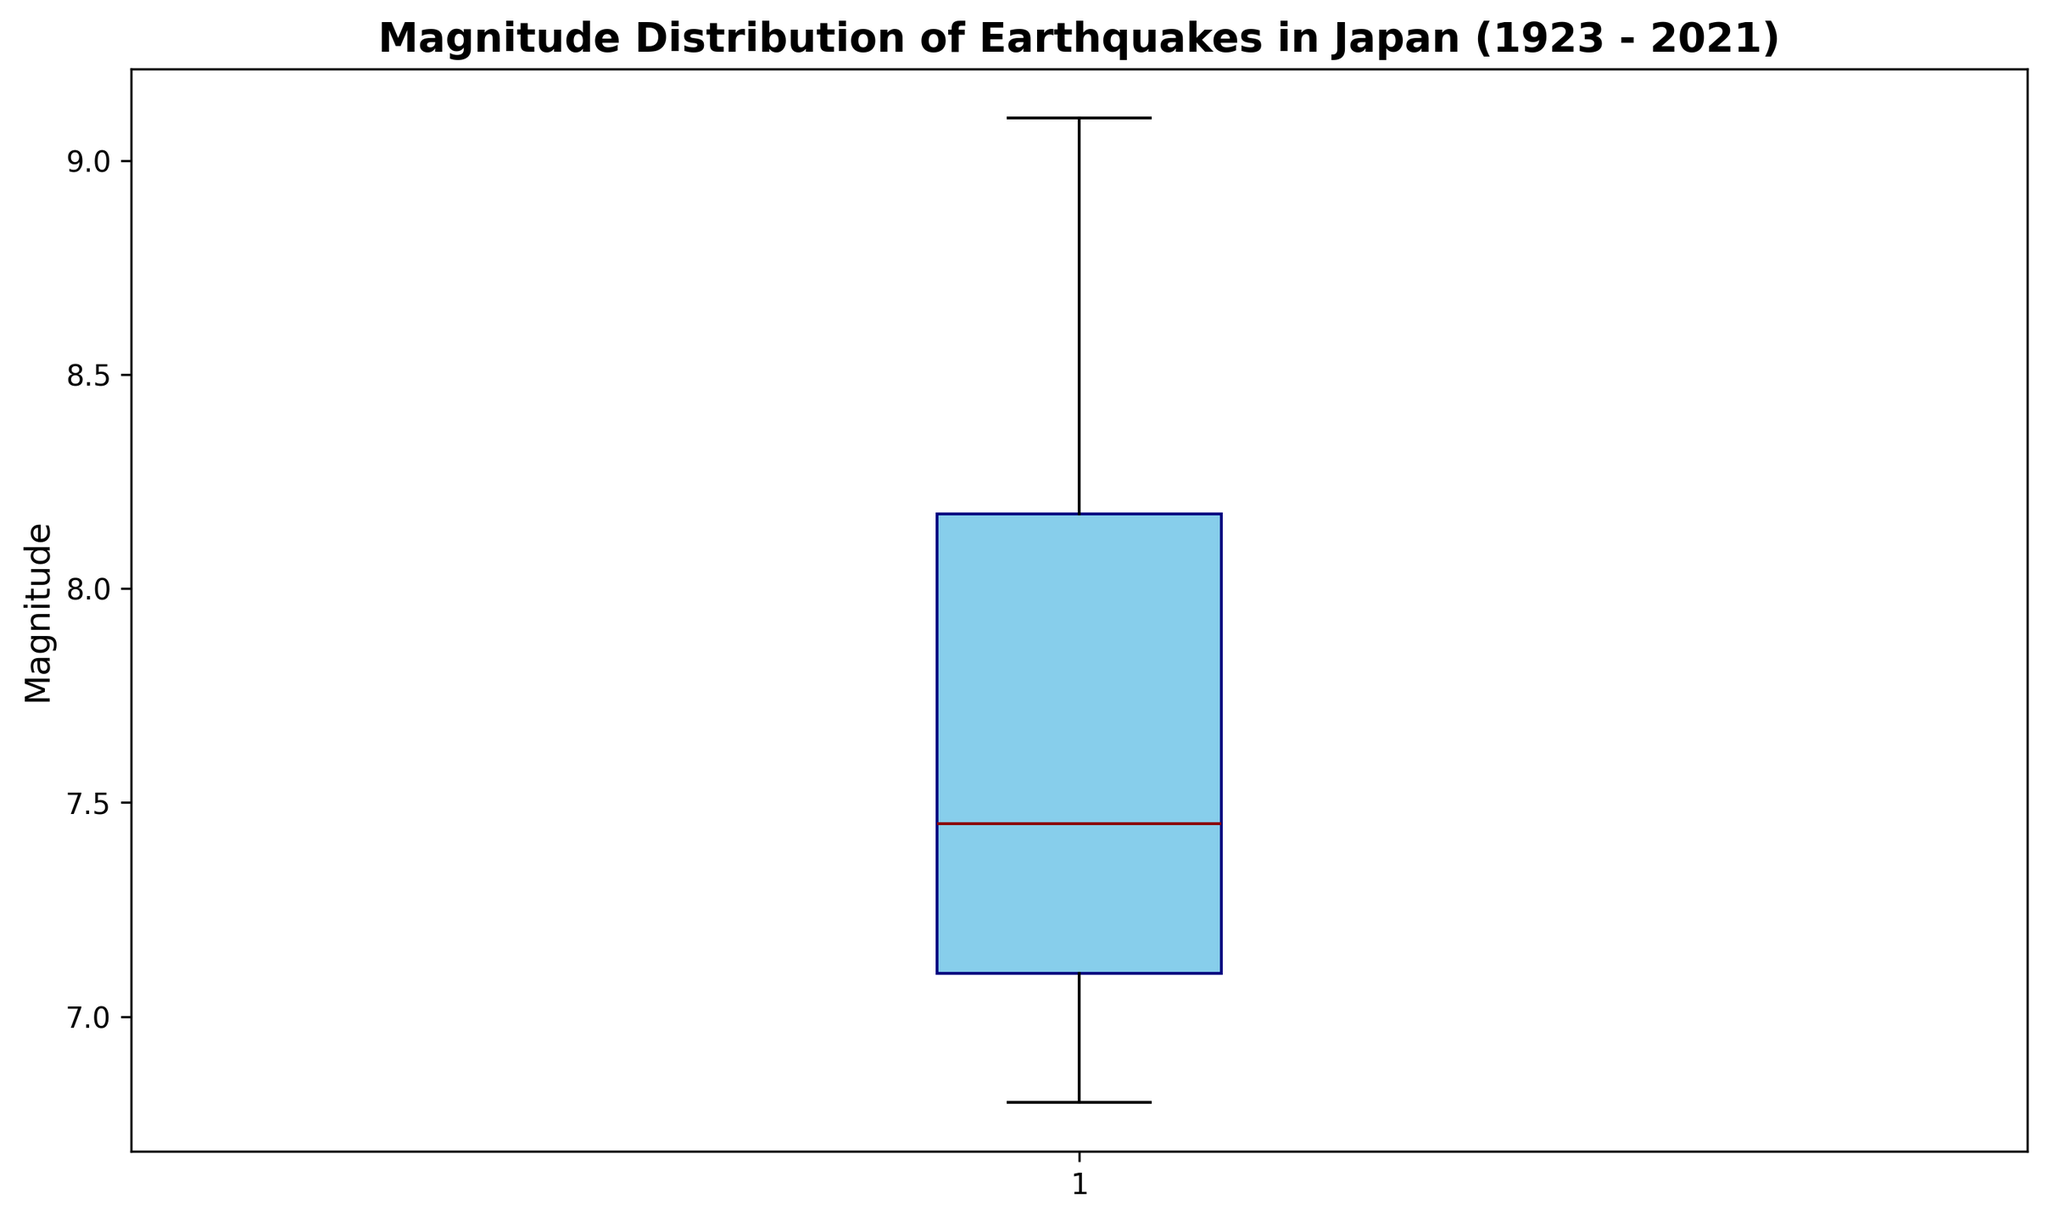What is the median magnitude of earthquakes in Japan over the last century? To find the median, look at the central value in the data set once ordered from smallest to largest. In the box plot, this is represented by the horizontal line inside the box.
Answer: 7.4 What is the range of earthquake magnitudes? The range is the difference between the maximum and minimum values. In the box plot, this is the distance between the top and bottom whiskers.
Answer: 9.1 - 6.8 How does the upper quartile compare to the lower quartile of earthquake magnitudes? The upper quartile (Q3) is the top of the box, and the lower quartile (Q1) is the bottom of the box. Compare their positions to see which is greater.
Answer: Upper quartile is higher Which visual element represents the variability in earthquake magnitudes, and how? The length of the box and the whiskers represents variability; the longer these elements, the greater the variability.
Answer: Length of box and whiskers Are there any outliers in the earthquake magnitude data? In a box plot, outliers are typically represented by points outside the whiskers. Look for any individual points beyond the whiskers.
Answer: No How does the median compare to the upper and lower quartiles of earthquake magnitudes? The median is the middle line within the box, while the upper quartile is the top line of the box and the lower quartile is the bottom line of the box. Compare their positions.
Answer: Median is between upper and lower quartiles By how much does the maximum earthquake magnitude exceed the median magnitude? Subtract the median value (inside line of the box) from the maximum value (top whisker).
Answer: 9.1 - 7.4 = 1.7 What is the interquartile range (IQR) of the earthquake magnitudes? The IQR is the difference between the upper quartile (top of the box) and the lower quartile (bottom of the box).
Answer: Q3 - Q1 What does the placement of the median line within the box indicate about the distribution of earthquake magnitudes? If the median line is closer to the bottom or top of the box, it indicates a skewed distribution. If it’s in the center, the distribution is symmetrical.
Answer: Near center, indicating symmetry How many earthquakes had a magnitude higher than the third quartile? Only outliers or points above the top whisker exceed the third quartile. Count any outliers representing magnitudes greater than this.
Answer: None 